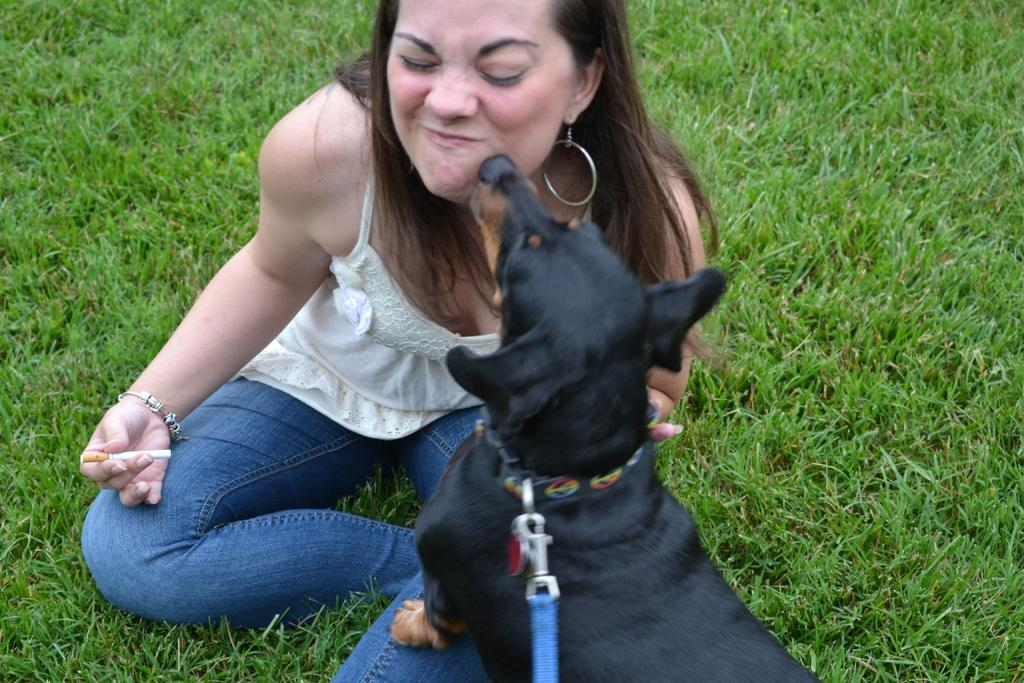Who is present in the image? There is a woman and a dog in the image. What is the setting of the image? The woman and the dog are sitting on a grass field. What type of meat is the woman feeding the dog in the image? There is no meat present in the image; the woman and the dog are sitting on a grass field. 